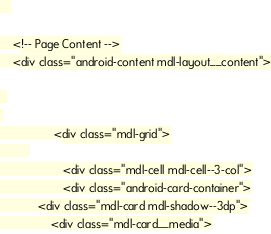<code> <loc_0><loc_0><loc_500><loc_500><_PHP_>
   

    <!-- Page Content -->
    <div class="android-content mdl-layout__content">

  
 
                 <div class="mdl-grid">
         
                    <div class="mdl-cell mdl-cell--3-col">
                    <div class="android-card-container">
            <div class="mdl-card mdl-shadow--3dp">
            	<div class="mdl-card__media"></code> 